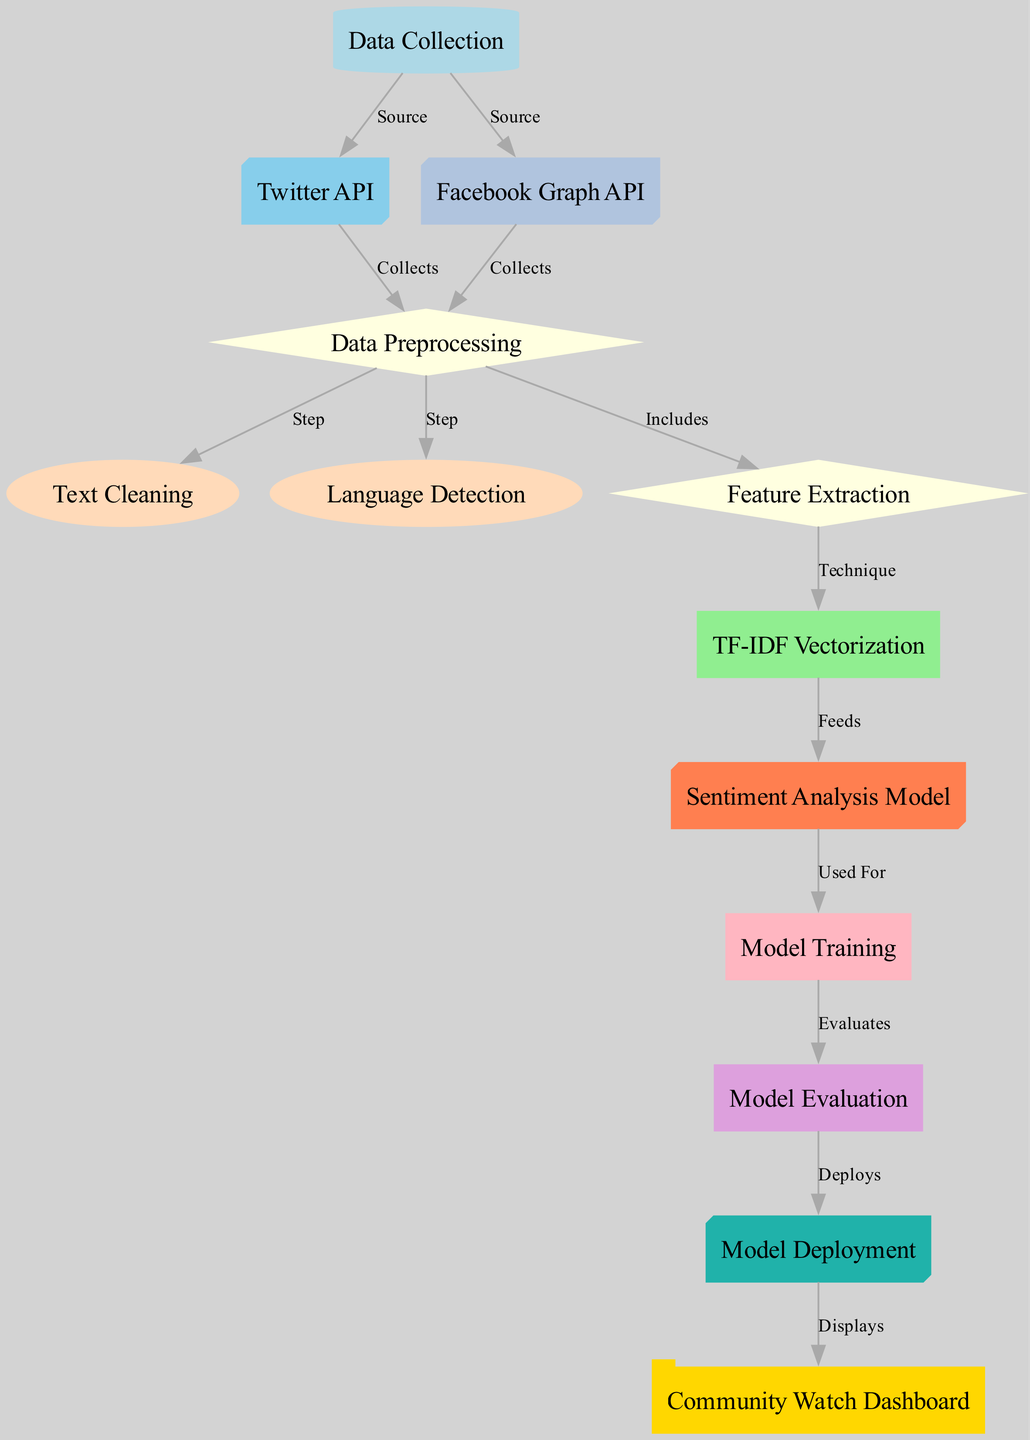What are the two sources of data collection? The diagram shows two nodes connected to the "Data Collection" node. They are "Twitter API" and "Facebook Graph API," indicating that these are the two sources from which data is collected.
Answer: Twitter API, Facebook Graph API How many nodes are there in the diagram? By counting all the nodes listed, there are thirteen distinct nodes in total, including primary processes and APIs utilized in the machine learning workflow.
Answer: thirteen What is the technique used for feature extraction? The edge connecting "Feature Extraction" and "TF-IDF Vectorization" specifies that TF-IDF Vectorization is the technique applied in this step.
Answer: TF-IDF Vectorization What comes after model evaluation? The "Model Deployment" node follows directly from "Model Evaluation" as shown in the diagram, indicating the next step after evaluating the model's performance.
Answer: Model Deployment Which node is displayed in the Community Watch Dashboard? The arrow leading from "Model Deployment" to "Community Watch Dashboard" indicates that the dashboard displays the results or outcomes of the model once it has been deployed.
Answer: Community Watch Dashboard How does data preprocessing relate to feature extraction? The edge labeled "Includes" connects "Data Preprocessing" to "Feature Extraction," implying that feature extraction is a part of the overall data preprocessing step.
Answer: Includes What is the relationship between the sentiment analysis model and model training? The edge labeled "Used For" shows that the "Sentiment Analysis Model" is used for "Model Training," indicating that the model is what will be trained on the available data next.
Answer: Used For Which phase is responsible for text cleaning? The node "Text Cleaning" is directly connected to "Data Preprocessing" as a step in the preprocessing process, emphasizing its role in preparing the data.
Answer: Text Cleaning How are the data sources involved in the data preprocessing step? Both "Twitter API" and "Facebook Graph API" feed into the "Data Preprocessing" node, indicating that the collected data from both sources is processed in this step.
Answer: Collects 